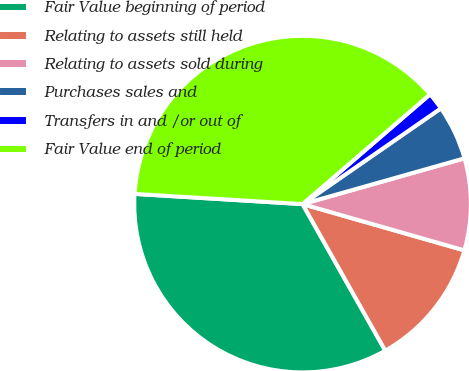Convert chart to OTSL. <chart><loc_0><loc_0><loc_500><loc_500><pie_chart><fcel>Fair Value beginning of period<fcel>Relating to assets still held<fcel>Relating to assets sold during<fcel>Purchases sales and<fcel>Transfers in and /or out of<fcel>Fair Value end of period<nl><fcel>34.15%<fcel>12.39%<fcel>8.82%<fcel>5.25%<fcel>1.68%<fcel>37.72%<nl></chart> 